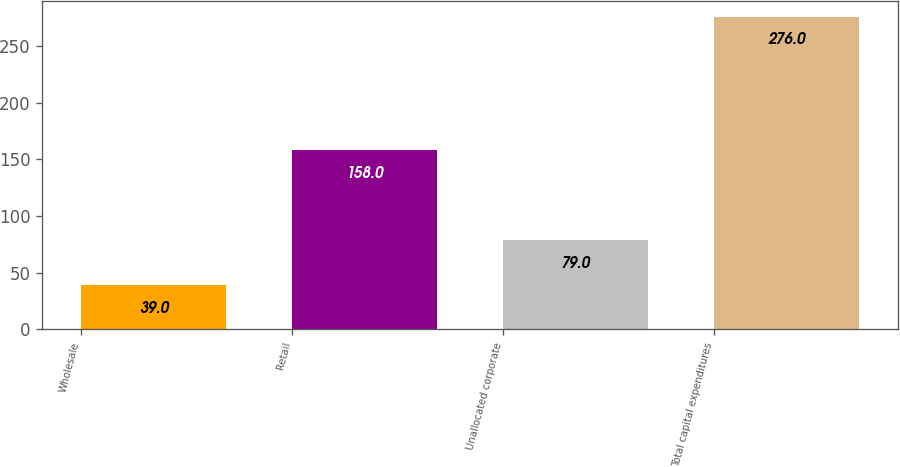Convert chart. <chart><loc_0><loc_0><loc_500><loc_500><bar_chart><fcel>Wholesale<fcel>Retail<fcel>Unallocated corporate<fcel>Total capital expenditures<nl><fcel>39<fcel>158<fcel>79<fcel>276<nl></chart> 